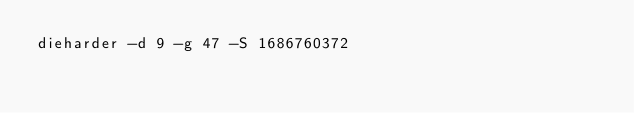Convert code to text. <code><loc_0><loc_0><loc_500><loc_500><_Bash_>dieharder -d 9 -g 47 -S 1686760372
</code> 